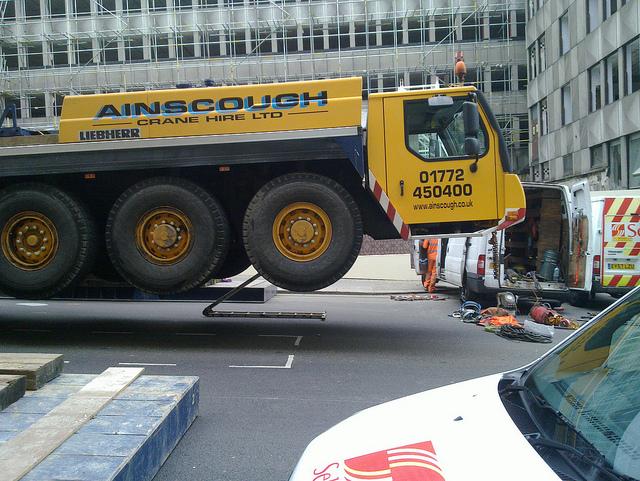What is the name of the crane company?
Write a very short answer. Ainscough. How many wheels does this vehicle have?
Be succinct. 6. What does this truck carry from job to job?
Write a very short answer. Crane. 